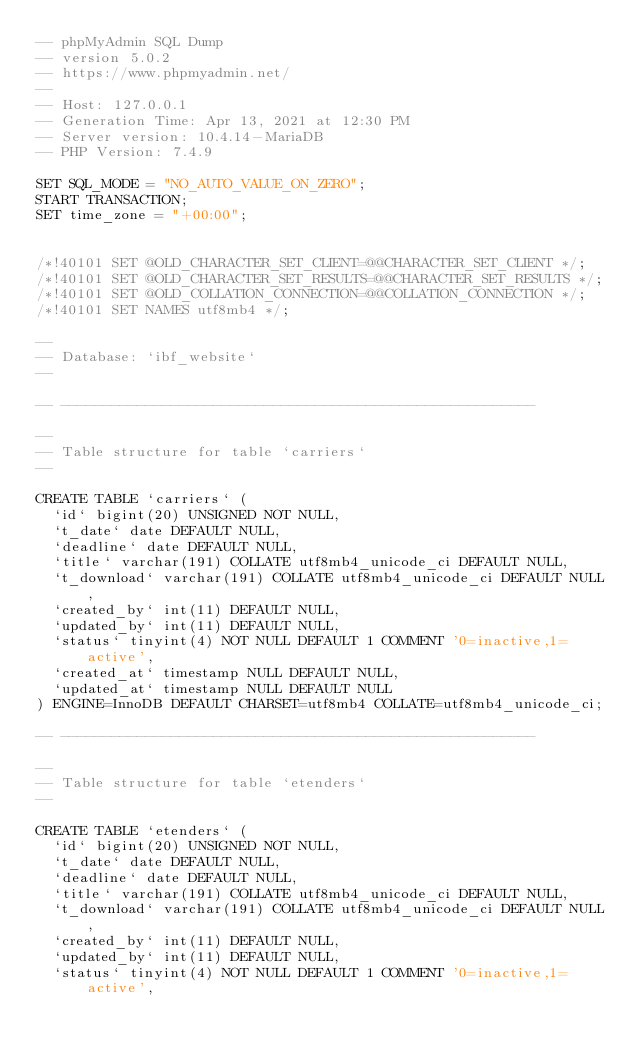Convert code to text. <code><loc_0><loc_0><loc_500><loc_500><_SQL_>-- phpMyAdmin SQL Dump
-- version 5.0.2
-- https://www.phpmyadmin.net/
--
-- Host: 127.0.0.1
-- Generation Time: Apr 13, 2021 at 12:30 PM
-- Server version: 10.4.14-MariaDB
-- PHP Version: 7.4.9

SET SQL_MODE = "NO_AUTO_VALUE_ON_ZERO";
START TRANSACTION;
SET time_zone = "+00:00";


/*!40101 SET @OLD_CHARACTER_SET_CLIENT=@@CHARACTER_SET_CLIENT */;
/*!40101 SET @OLD_CHARACTER_SET_RESULTS=@@CHARACTER_SET_RESULTS */;
/*!40101 SET @OLD_COLLATION_CONNECTION=@@COLLATION_CONNECTION */;
/*!40101 SET NAMES utf8mb4 */;

--
-- Database: `ibf_website`
--

-- --------------------------------------------------------

--
-- Table structure for table `carriers`
--

CREATE TABLE `carriers` (
  `id` bigint(20) UNSIGNED NOT NULL,
  `t_date` date DEFAULT NULL,
  `deadline` date DEFAULT NULL,
  `title` varchar(191) COLLATE utf8mb4_unicode_ci DEFAULT NULL,
  `t_download` varchar(191) COLLATE utf8mb4_unicode_ci DEFAULT NULL,
  `created_by` int(11) DEFAULT NULL,
  `updated_by` int(11) DEFAULT NULL,
  `status` tinyint(4) NOT NULL DEFAULT 1 COMMENT '0=inactive,1=active',
  `created_at` timestamp NULL DEFAULT NULL,
  `updated_at` timestamp NULL DEFAULT NULL
) ENGINE=InnoDB DEFAULT CHARSET=utf8mb4 COLLATE=utf8mb4_unicode_ci;

-- --------------------------------------------------------

--
-- Table structure for table `etenders`
--

CREATE TABLE `etenders` (
  `id` bigint(20) UNSIGNED NOT NULL,
  `t_date` date DEFAULT NULL,
  `deadline` date DEFAULT NULL,
  `title` varchar(191) COLLATE utf8mb4_unicode_ci DEFAULT NULL,
  `t_download` varchar(191) COLLATE utf8mb4_unicode_ci DEFAULT NULL,
  `created_by` int(11) DEFAULT NULL,
  `updated_by` int(11) DEFAULT NULL,
  `status` tinyint(4) NOT NULL DEFAULT 1 COMMENT '0=inactive,1=active',</code> 